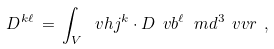<formula> <loc_0><loc_0><loc_500><loc_500>D ^ { k \ell } \, = \, \int _ { V } \, \ v h j ^ { k } \cdot D \ v b ^ { \ell } \, \ m d ^ { 3 } \ v v r \ ,</formula> 